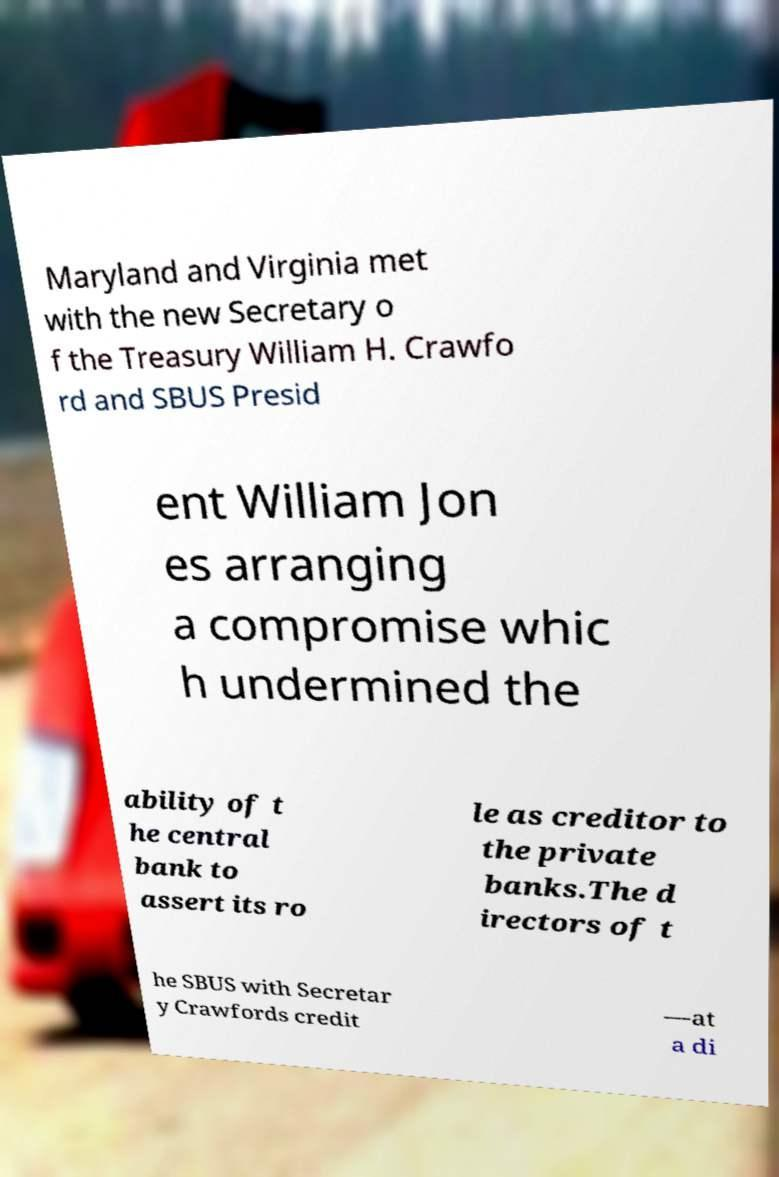What messages or text are displayed in this image? I need them in a readable, typed format. Maryland and Virginia met with the new Secretary o f the Treasury William H. Crawfo rd and SBUS Presid ent William Jon es arranging a compromise whic h undermined the ability of t he central bank to assert its ro le as creditor to the private banks.The d irectors of t he SBUS with Secretar y Crawfords credit —at a di 